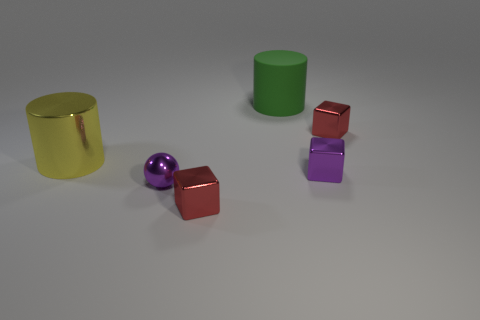Is the yellow object made of the same material as the big object that is on the right side of the small sphere?
Offer a terse response. No. How many objects are either big matte cylinders or tiny purple things to the right of the purple ball?
Provide a succinct answer. 2. There is a metallic object that is behind the metal cylinder; does it have the same size as the purple object left of the green thing?
Your answer should be compact. Yes. What number of other objects are the same color as the tiny sphere?
Offer a very short reply. 1. Do the metal sphere and the purple metal thing that is right of the big green matte object have the same size?
Ensure brevity in your answer.  Yes. What size is the red shiny cube that is on the left side of the red shiny block right of the big green rubber object?
Your answer should be compact. Small. There is another object that is the same shape as the green thing; what color is it?
Give a very brief answer. Yellow. Do the shiny cylinder and the purple block have the same size?
Your answer should be compact. No. Is the number of metallic things in front of the small purple cube the same as the number of large things?
Provide a short and direct response. Yes. Is there a object that is on the left side of the big thing that is behind the shiny cylinder?
Keep it short and to the point. Yes. 